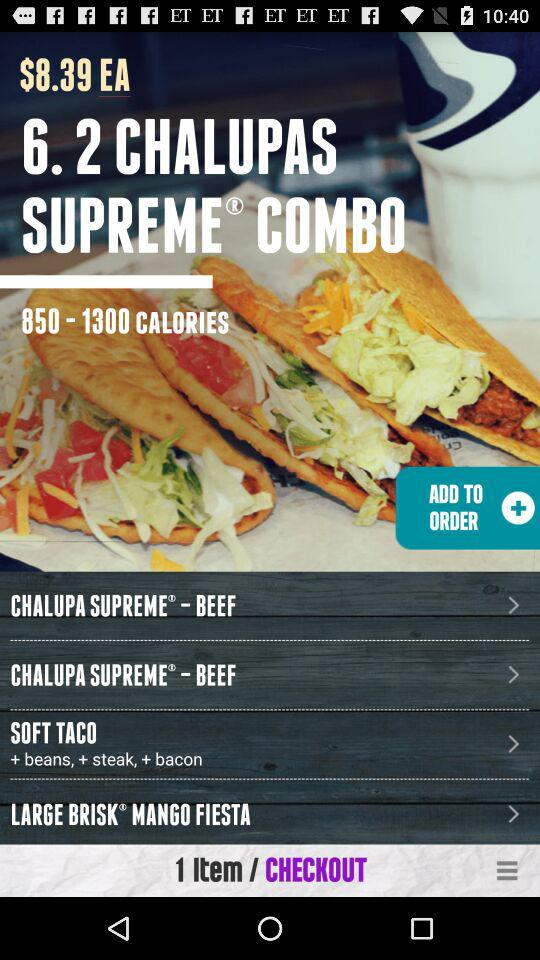What ingredients are in "SOFT TACO"? The ingredients in "SOFT TACO" are beans, steak and bacon. 